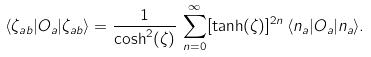<formula> <loc_0><loc_0><loc_500><loc_500>\langle \zeta _ { a b } | O _ { a } | \zeta _ { a b } \rangle = \frac { 1 } { \cosh ^ { 2 } ( \zeta ) } \, \sum _ { n = 0 } ^ { \infty } [ \tanh ( \zeta ) ] ^ { 2 n } \, \langle n _ { a } | O _ { a } | n _ { a } \rangle .</formula> 